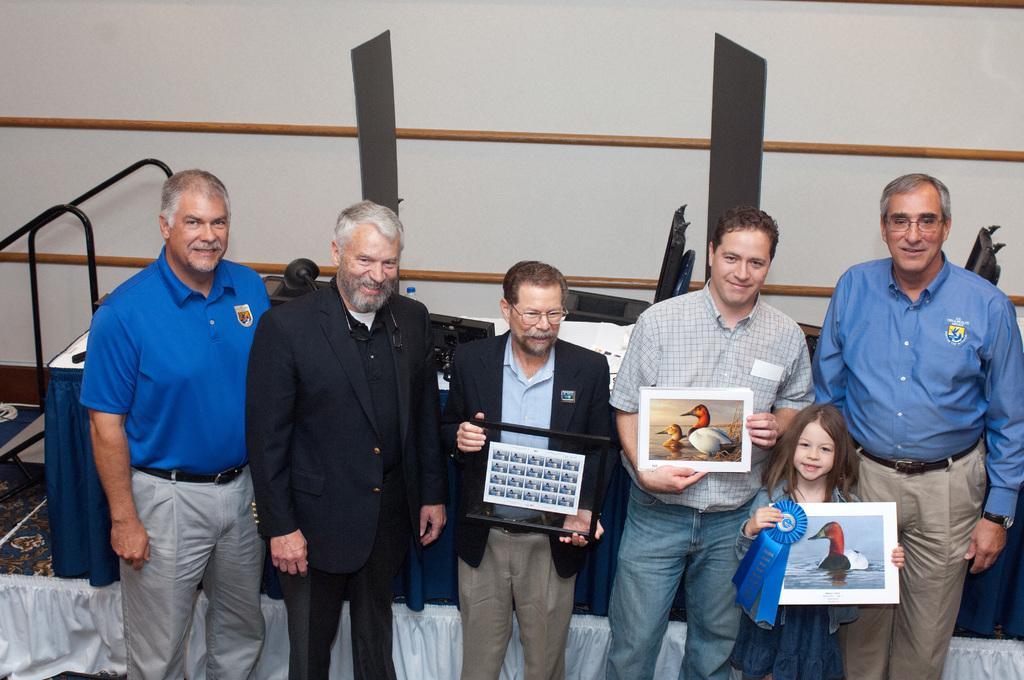Can you describe this image briefly? There is a group of persons standing as we can see at the bottom of this image. We can see three people are holding some photo frames. We can see chairs, table and a wall in the background. 